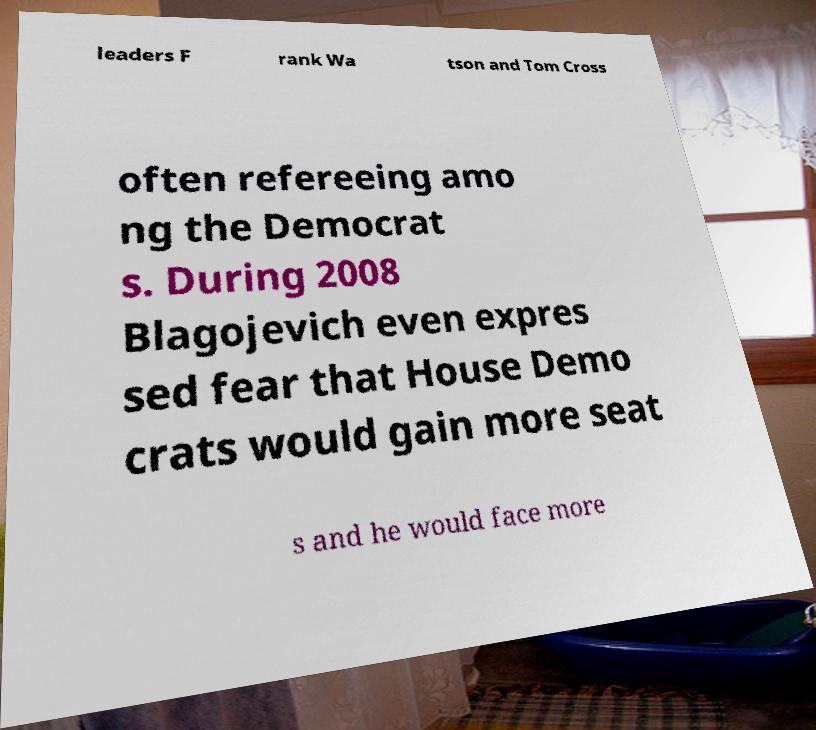Can you accurately transcribe the text from the provided image for me? leaders F rank Wa tson and Tom Cross often refereeing amo ng the Democrat s. During 2008 Blagojevich even expres sed fear that House Demo crats would gain more seat s and he would face more 